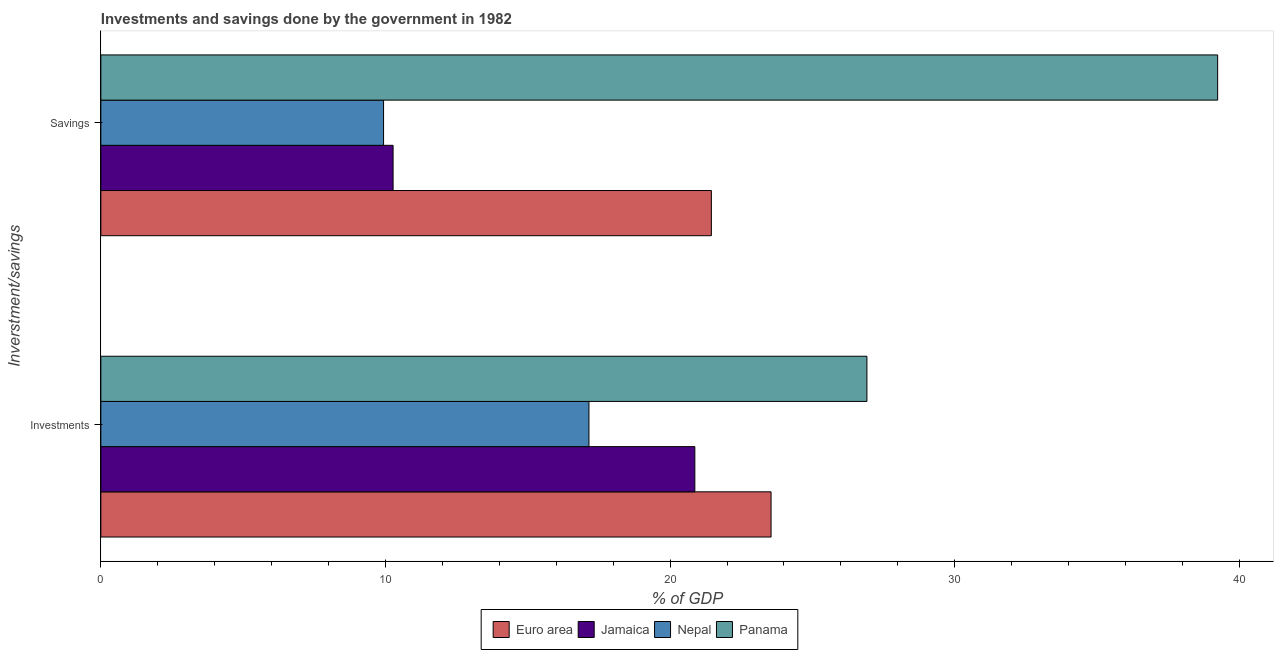How many different coloured bars are there?
Provide a short and direct response. 4. How many groups of bars are there?
Your answer should be compact. 2. How many bars are there on the 2nd tick from the top?
Offer a terse response. 4. How many bars are there on the 1st tick from the bottom?
Provide a succinct answer. 4. What is the label of the 1st group of bars from the top?
Provide a short and direct response. Savings. What is the savings of government in Euro area?
Offer a very short reply. 21.45. Across all countries, what is the maximum investments of government?
Make the answer very short. 26.91. Across all countries, what is the minimum investments of government?
Your answer should be very brief. 17.15. In which country was the investments of government maximum?
Offer a terse response. Panama. In which country was the investments of government minimum?
Offer a terse response. Nepal. What is the total savings of government in the graph?
Give a very brief answer. 80.89. What is the difference between the savings of government in Euro area and that in Nepal?
Offer a terse response. 11.52. What is the difference between the investments of government in Nepal and the savings of government in Euro area?
Your answer should be very brief. -4.3. What is the average savings of government per country?
Give a very brief answer. 20.22. What is the difference between the savings of government and investments of government in Jamaica?
Offer a very short reply. -10.6. In how many countries, is the savings of government greater than 18 %?
Give a very brief answer. 2. What is the ratio of the savings of government in Jamaica to that in Euro area?
Offer a terse response. 0.48. Is the savings of government in Nepal less than that in Jamaica?
Provide a succinct answer. Yes. In how many countries, is the savings of government greater than the average savings of government taken over all countries?
Ensure brevity in your answer.  2. What does the 1st bar from the top in Savings represents?
Offer a terse response. Panama. How many bars are there?
Ensure brevity in your answer.  8. How many countries are there in the graph?
Offer a terse response. 4. How many legend labels are there?
Your answer should be compact. 4. What is the title of the graph?
Offer a terse response. Investments and savings done by the government in 1982. Does "Croatia" appear as one of the legend labels in the graph?
Provide a short and direct response. No. What is the label or title of the X-axis?
Give a very brief answer. % of GDP. What is the label or title of the Y-axis?
Your answer should be compact. Inverstment/savings. What is the % of GDP in Euro area in Investments?
Offer a very short reply. 23.55. What is the % of GDP in Jamaica in Investments?
Provide a short and direct response. 20.87. What is the % of GDP of Nepal in Investments?
Keep it short and to the point. 17.15. What is the % of GDP in Panama in Investments?
Provide a short and direct response. 26.91. What is the % of GDP of Euro area in Savings?
Keep it short and to the point. 21.45. What is the % of GDP in Jamaica in Savings?
Ensure brevity in your answer.  10.27. What is the % of GDP in Nepal in Savings?
Provide a short and direct response. 9.93. What is the % of GDP in Panama in Savings?
Give a very brief answer. 39.24. Across all Inverstment/savings, what is the maximum % of GDP of Euro area?
Your response must be concise. 23.55. Across all Inverstment/savings, what is the maximum % of GDP in Jamaica?
Make the answer very short. 20.87. Across all Inverstment/savings, what is the maximum % of GDP in Nepal?
Offer a terse response. 17.15. Across all Inverstment/savings, what is the maximum % of GDP of Panama?
Make the answer very short. 39.24. Across all Inverstment/savings, what is the minimum % of GDP of Euro area?
Give a very brief answer. 21.45. Across all Inverstment/savings, what is the minimum % of GDP in Jamaica?
Keep it short and to the point. 10.27. Across all Inverstment/savings, what is the minimum % of GDP in Nepal?
Make the answer very short. 9.93. Across all Inverstment/savings, what is the minimum % of GDP in Panama?
Offer a terse response. 26.91. What is the total % of GDP in Euro area in the graph?
Keep it short and to the point. 45. What is the total % of GDP of Jamaica in the graph?
Your answer should be compact. 31.14. What is the total % of GDP of Nepal in the graph?
Offer a very short reply. 27.08. What is the total % of GDP of Panama in the graph?
Provide a short and direct response. 66.15. What is the difference between the % of GDP of Euro area in Investments and that in Savings?
Ensure brevity in your answer.  2.1. What is the difference between the % of GDP in Jamaica in Investments and that in Savings?
Give a very brief answer. 10.6. What is the difference between the % of GDP of Nepal in Investments and that in Savings?
Provide a short and direct response. 7.22. What is the difference between the % of GDP in Panama in Investments and that in Savings?
Your answer should be compact. -12.32. What is the difference between the % of GDP of Euro area in Investments and the % of GDP of Jamaica in Savings?
Ensure brevity in your answer.  13.28. What is the difference between the % of GDP of Euro area in Investments and the % of GDP of Nepal in Savings?
Offer a terse response. 13.61. What is the difference between the % of GDP of Euro area in Investments and the % of GDP of Panama in Savings?
Offer a very short reply. -15.69. What is the difference between the % of GDP of Jamaica in Investments and the % of GDP of Nepal in Savings?
Your answer should be very brief. 10.94. What is the difference between the % of GDP in Jamaica in Investments and the % of GDP in Panama in Savings?
Your response must be concise. -18.37. What is the difference between the % of GDP in Nepal in Investments and the % of GDP in Panama in Savings?
Your answer should be compact. -22.09. What is the average % of GDP of Euro area per Inverstment/savings?
Give a very brief answer. 22.5. What is the average % of GDP in Jamaica per Inverstment/savings?
Offer a terse response. 15.57. What is the average % of GDP of Nepal per Inverstment/savings?
Provide a succinct answer. 13.54. What is the average % of GDP of Panama per Inverstment/savings?
Offer a very short reply. 33.08. What is the difference between the % of GDP of Euro area and % of GDP of Jamaica in Investments?
Your answer should be compact. 2.68. What is the difference between the % of GDP of Euro area and % of GDP of Nepal in Investments?
Your answer should be compact. 6.4. What is the difference between the % of GDP in Euro area and % of GDP in Panama in Investments?
Give a very brief answer. -3.37. What is the difference between the % of GDP in Jamaica and % of GDP in Nepal in Investments?
Give a very brief answer. 3.72. What is the difference between the % of GDP in Jamaica and % of GDP in Panama in Investments?
Give a very brief answer. -6.05. What is the difference between the % of GDP of Nepal and % of GDP of Panama in Investments?
Provide a short and direct response. -9.77. What is the difference between the % of GDP in Euro area and % of GDP in Jamaica in Savings?
Keep it short and to the point. 11.18. What is the difference between the % of GDP in Euro area and % of GDP in Nepal in Savings?
Give a very brief answer. 11.52. What is the difference between the % of GDP of Euro area and % of GDP of Panama in Savings?
Provide a short and direct response. -17.79. What is the difference between the % of GDP of Jamaica and % of GDP of Nepal in Savings?
Ensure brevity in your answer.  0.33. What is the difference between the % of GDP of Jamaica and % of GDP of Panama in Savings?
Offer a terse response. -28.97. What is the difference between the % of GDP of Nepal and % of GDP of Panama in Savings?
Your answer should be compact. -29.3. What is the ratio of the % of GDP of Euro area in Investments to that in Savings?
Make the answer very short. 1.1. What is the ratio of the % of GDP in Jamaica in Investments to that in Savings?
Make the answer very short. 2.03. What is the ratio of the % of GDP in Nepal in Investments to that in Savings?
Your answer should be compact. 1.73. What is the ratio of the % of GDP of Panama in Investments to that in Savings?
Give a very brief answer. 0.69. What is the difference between the highest and the second highest % of GDP in Euro area?
Keep it short and to the point. 2.1. What is the difference between the highest and the second highest % of GDP of Jamaica?
Offer a very short reply. 10.6. What is the difference between the highest and the second highest % of GDP in Nepal?
Make the answer very short. 7.22. What is the difference between the highest and the second highest % of GDP in Panama?
Make the answer very short. 12.32. What is the difference between the highest and the lowest % of GDP of Euro area?
Make the answer very short. 2.1. What is the difference between the highest and the lowest % of GDP in Jamaica?
Offer a terse response. 10.6. What is the difference between the highest and the lowest % of GDP in Nepal?
Offer a terse response. 7.22. What is the difference between the highest and the lowest % of GDP of Panama?
Your response must be concise. 12.32. 